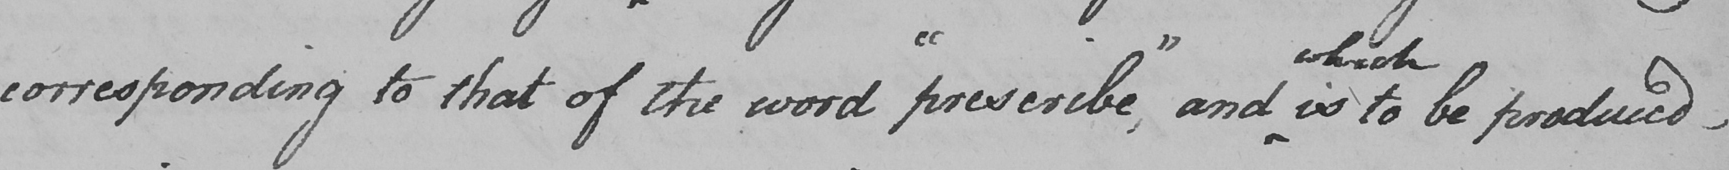Can you read and transcribe this handwriting? corresponding to that of the word  " prescribe , "  and is to be produced  _ 